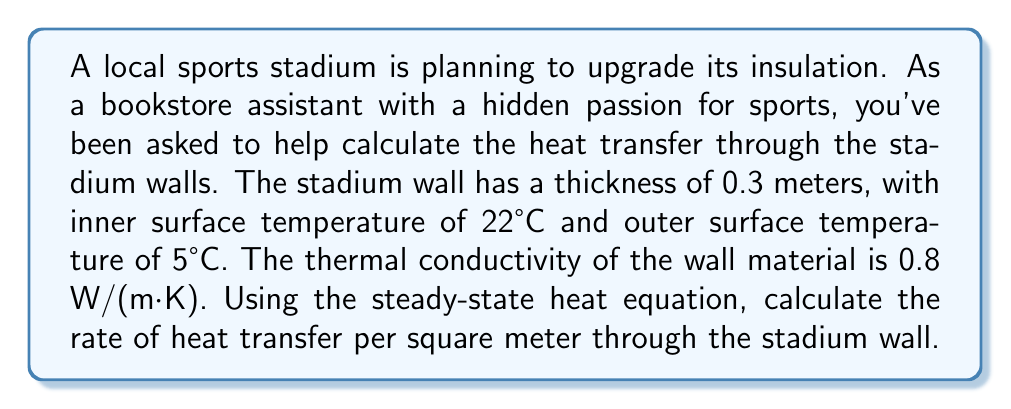Can you solve this math problem? To solve this problem, we'll use the steady-state heat equation in one dimension:

$$q = -k \frac{dT}{dx}$$

Where:
$q$ = heat flux (W/m²)
$k$ = thermal conductivity (W/(m·K))
$\frac{dT}{dx}$ = temperature gradient (K/m)

For steady-state conditions in a plane wall, we can simplify this to:

$$q = k \frac{T_2 - T_1}{L}$$

Where:
$T_2$ = temperature of the warmer side (inner surface)
$T_1$ = temperature of the cooler side (outer surface)
$L$ = thickness of the wall

Given:
$k = 0.8$ W/(m·K)
$T_2 = 22°C = 295.15$ K
$T_1 = 5°C = 278.15$ K
$L = 0.3$ m

Substituting these values into the equation:

$$q = 0.8 \frac{295.15 - 278.15}{0.3}$$

$$q = 0.8 \frac{17}{0.3}$$

$$q = 0.8 \cdot 56.67$$

$$q = 45.33 \text{ W/m²}$$

The negative sign is omitted as we're interested in the magnitude of heat transfer.
Answer: 45.33 W/m² 